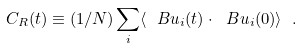<formula> <loc_0><loc_0><loc_500><loc_500>C _ { R } ( t ) \equiv ( 1 / N ) \sum _ { i } \langle \ B u _ { i } ( t ) \cdot \ B u _ { i } ( 0 ) \rangle \ .</formula> 